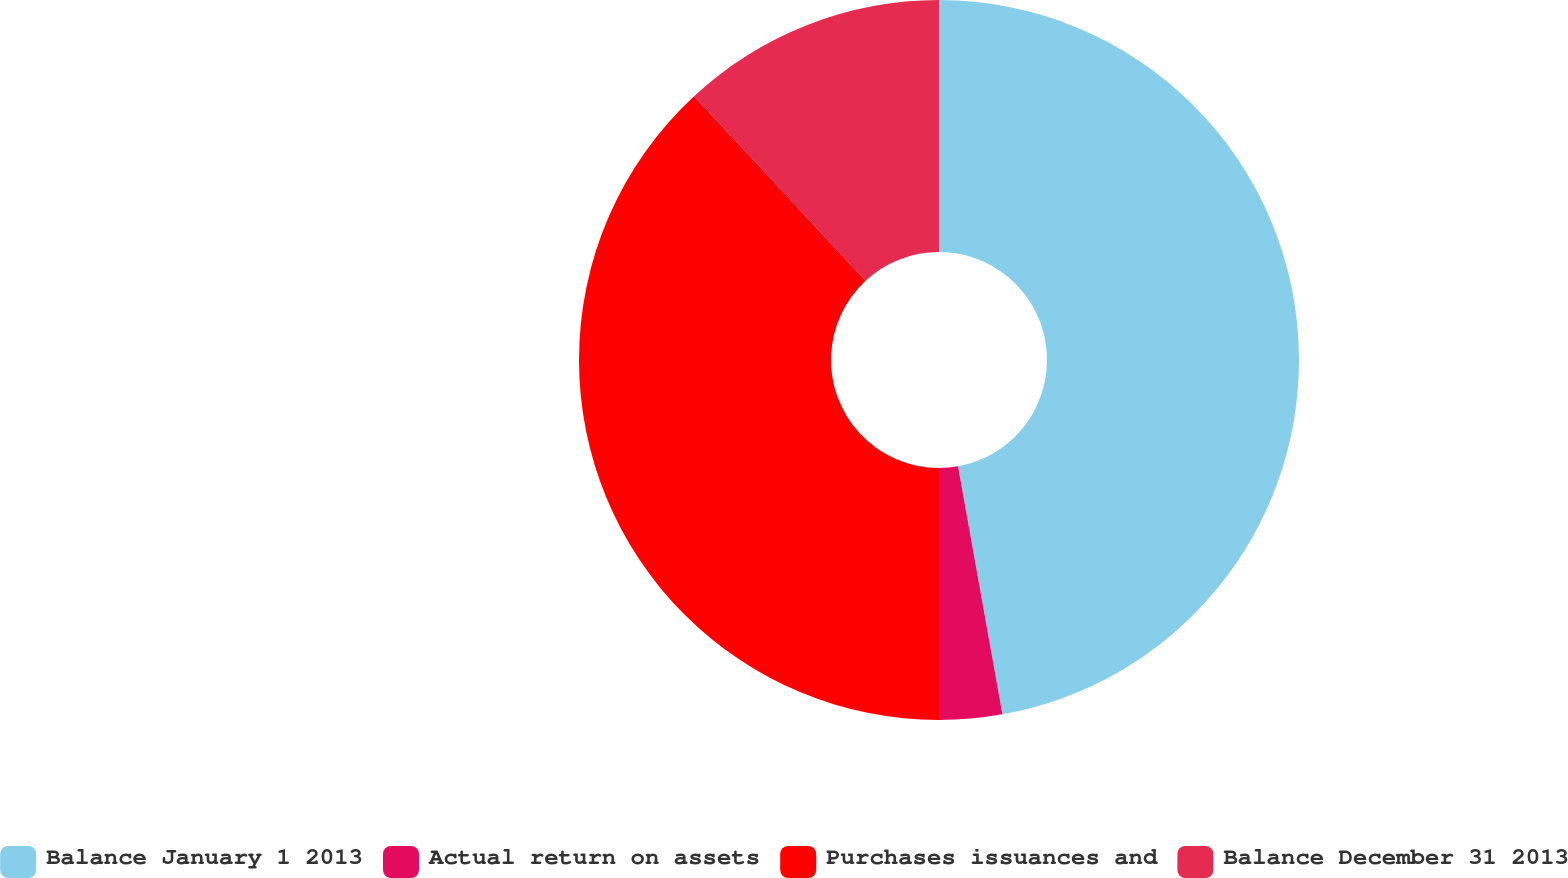Convert chart to OTSL. <chart><loc_0><loc_0><loc_500><loc_500><pie_chart><fcel>Balance January 1 2013<fcel>Actual return on assets<fcel>Purchases issuances and<fcel>Balance December 31 2013<nl><fcel>47.18%<fcel>2.82%<fcel>38.09%<fcel>11.91%<nl></chart> 